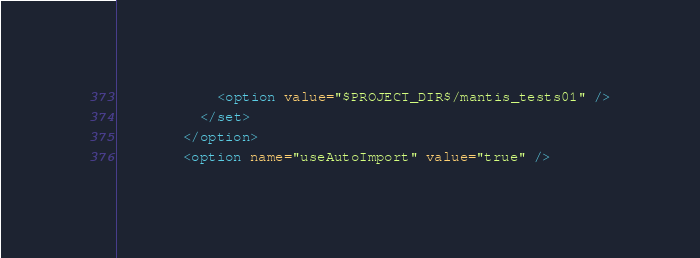Convert code to text. <code><loc_0><loc_0><loc_500><loc_500><_XML_>            <option value="$PROJECT_DIR$/mantis_tests01" />
          </set>
        </option>
        <option name="useAutoImport" value="true" /></code> 